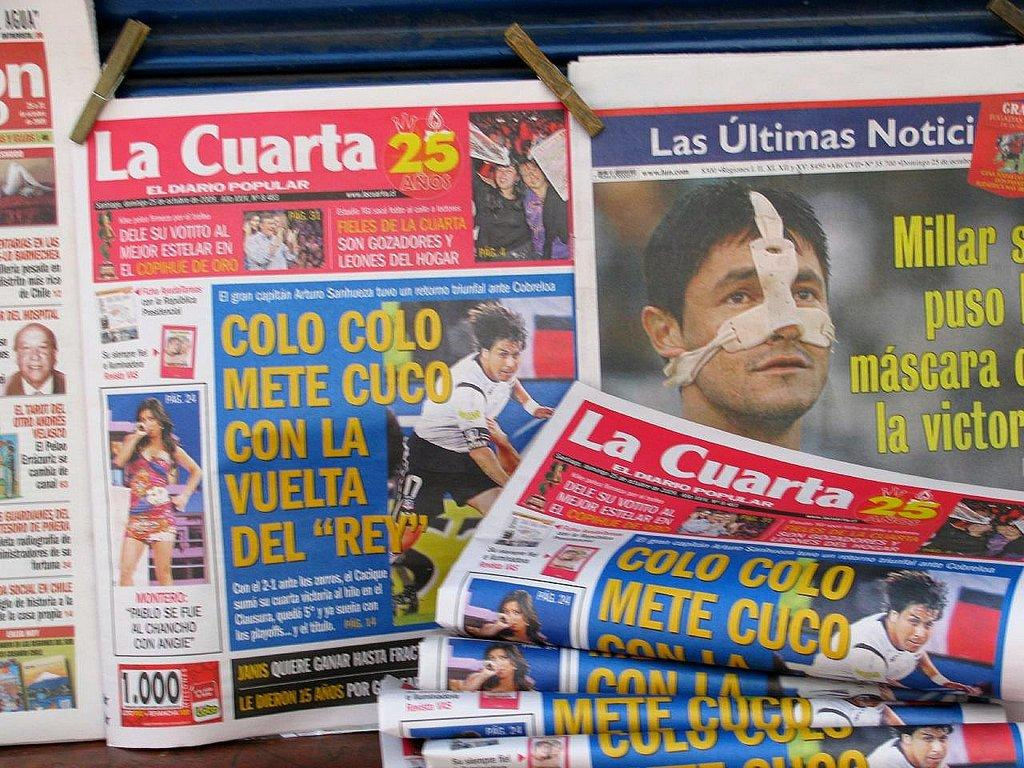What type of content is featured on the newspapers in the image? There are pictures of people printed on newspapers in the image. What else can be seen in the image besides the newspapers? There is text and logos in the image. What might be used to hold or display the newspapers? There are holders in the image. What type of jelly can be seen on the front of the bag in the image? There is no bag or jelly present in the image. 